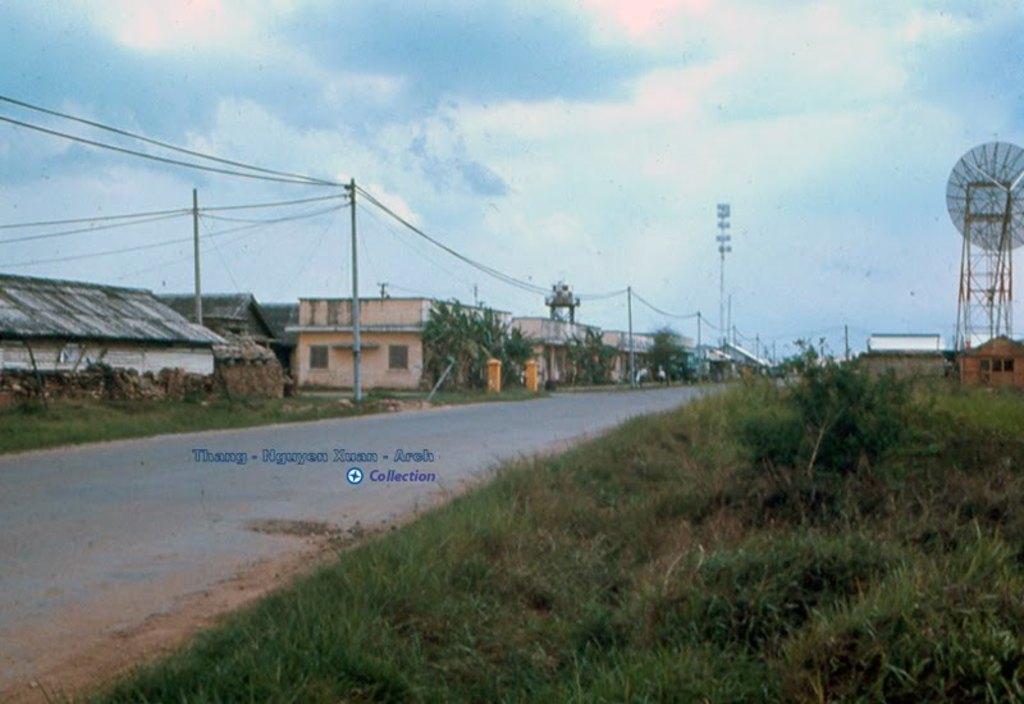Describe this image in one or two sentences. This picture is taken from the outside of the city. In this image, on the right side, we can see some plants and grass. On the right side, we can also see a house, satellite tower, building. On the left side, we can also see some houses, buildings, trees, plants, electric pole, electric wires. In the background, we can also see electric pole, electric wires, pole, trees, plants. At the top, we can see a sky, at the bottom, we can see a road and a grass. 